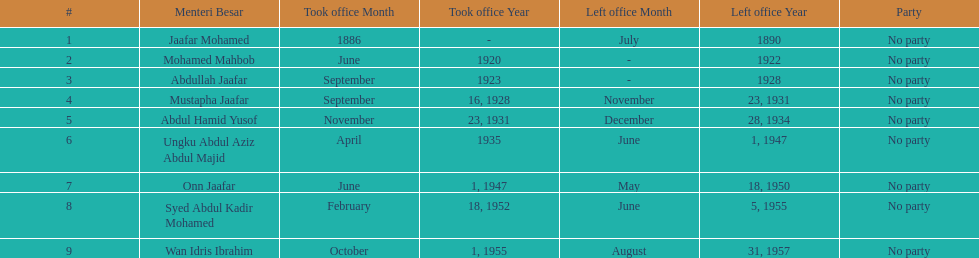Who is listed below onn jaafar? Syed Abdul Kadir Mohamed. 